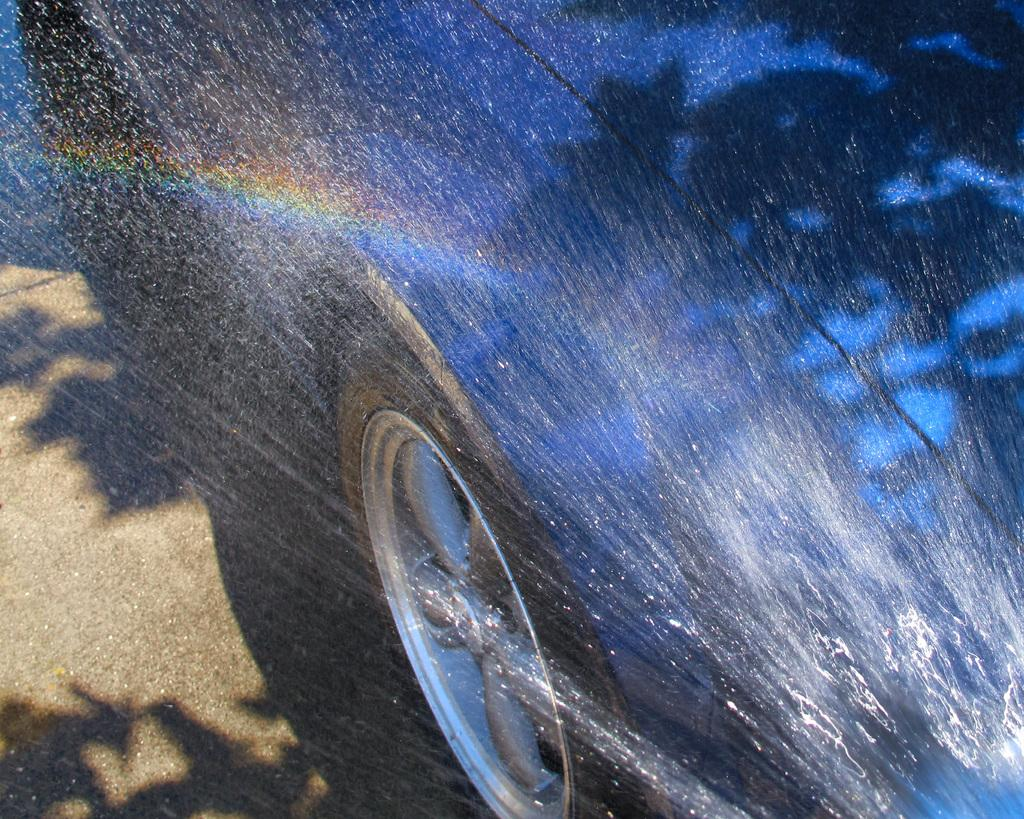What is the main subject of the image? There is a car in the image. What else can be seen in the image besides the car? There is water visible in the image. What is the range of the lake in the image? There is no lake present in the image, so the concept of range does not apply. 